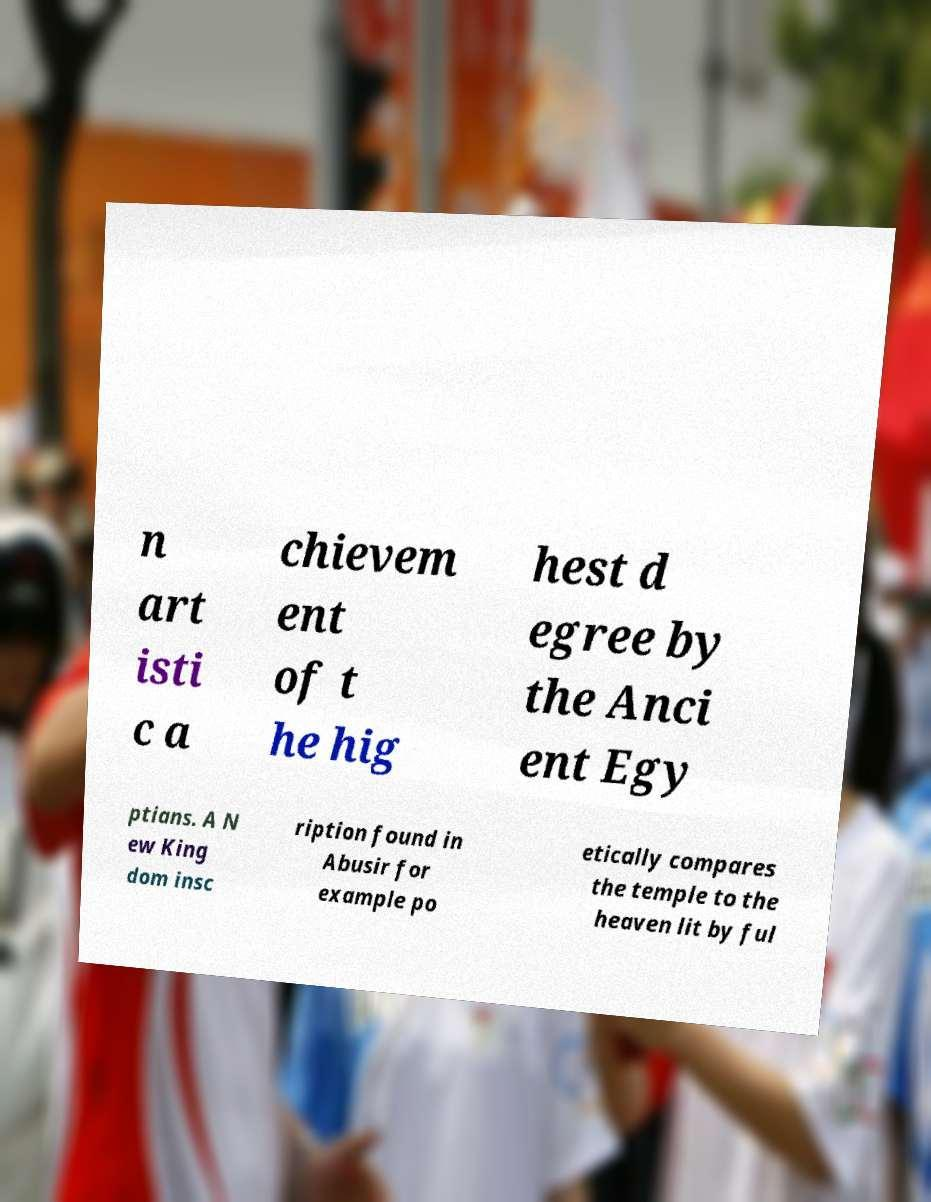Please read and relay the text visible in this image. What does it say? n art isti c a chievem ent of t he hig hest d egree by the Anci ent Egy ptians. A N ew King dom insc ription found in Abusir for example po etically compares the temple to the heaven lit by ful 